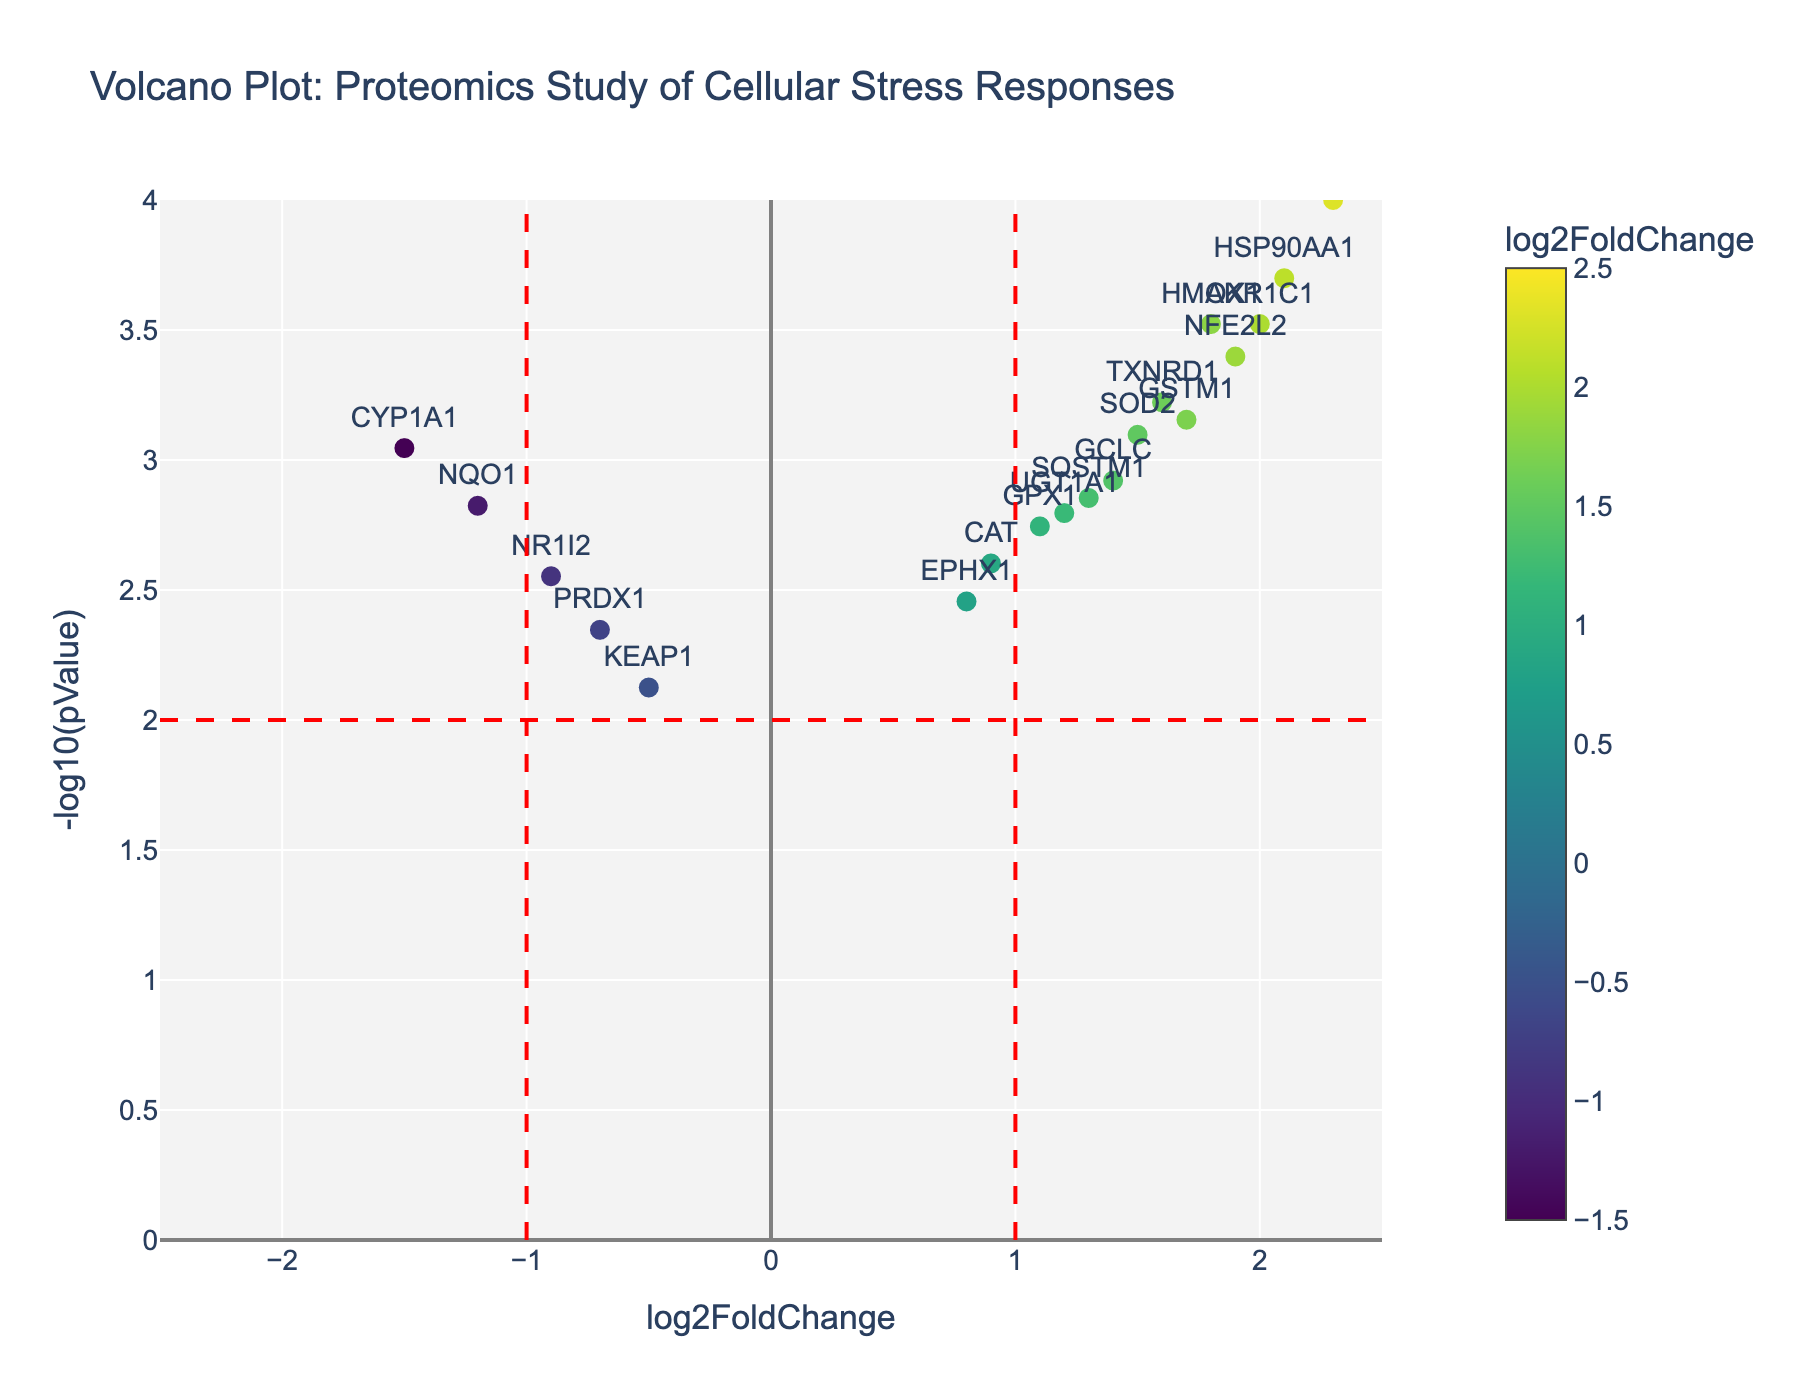What is the title of the volcano plot? The title of the plot is located at the top and summarizes the content of the figure.
Answer: Volcano Plot: Proteomics Study of Cellular Stress Responses What are the x and y axes labels in the plot? The x-axis label indicates it shows "log2FoldChange," and the y-axis label shows "-log10(pValue)."
Answer: x-axis: log2FoldChange, y-axis: -log10(pValue) How many genes are marked in the plot? Each point in the plot represents a gene. Simply count the number of points or gene labels.
Answer: 20 Which gene has the highest log2 fold change? By looking at the x-axis, you can identify the point farthest to the right. The gene in question is labeled.
Answer: GSTA1 Which gene has the lowest -log10(pValue)? By looking at the y-axis, you can identify the point closest to zero. The gene in question is labeled.
Answer: KEAP1 How many genes have a log2 fold change greater than 1? Count the number of points (gene labels) that are located to the right of the vertical dashed line at log2 fold change = 1.
Answer: 10 Which genes have a log2 fold change less than -1 and a p-value less than 0.001? Look for points on the left side of the plot beyond the vertical dashed line at log2 fold change = -1 and above the horizontal dashed line at -log10(pValue) = 3 (corresponding to p-value = 0.001).
Answer: NQO1, CYP1A1 Which gene is closer to the origin but has a significant p-value? Identify the gene that is close to (0,0) but above the horizontal dashed line indicating significance.
Answer: KEAP1 What colors are used to visualize the log2 fold change values, and what does the color scale represent? The colors vary from light to dark on a Viridis colorscale, which indicates the magnitude of log2FoldChange from negative to positive values.
Answer: Viridis colorscale, log2 fold change 